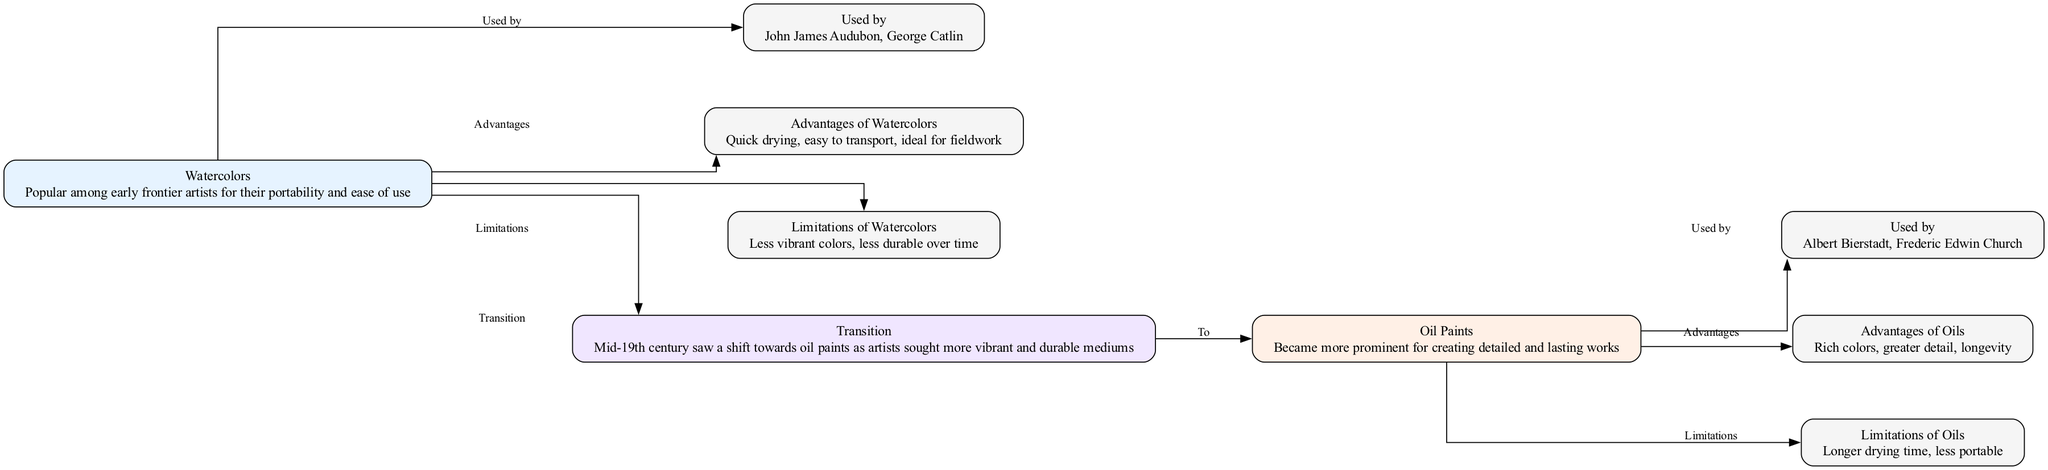What are the advantages of watercolors? The diagram lists advantages under the "Watercolors" node. Specifically, it mentions "Quick drying, easy to transport, ideal for fieldwork".
Answer: Quick drying, easy to transport, ideal for fieldwork Who are two artists that used oil paints? The "Used by" node linked to "Oil Paints" shows the names of artists. The diagram identifies "Albert Bierstadt, Frederic Edwin Church".
Answer: Albert Bierstadt, Frederic Edwin Church How many nodes are present in the diagram? Counting all unique nodes as listed in the diagram, there are a total of 9 nodes: watercolors, used by, advantages of watercolors, limitations of watercolors, transition, oil paints, used by oil, advantages of oils, limitations of oils.
Answer: 9 What transition occurred in the mid-19th century? The "Transition" node states that "Mid-19th century saw a shift towards oil paints as artists sought more vibrant and durable mediums". This indicates the movement from watercolors to oil paints.
Answer: Shift towards oil paints What are the limitations of oil paints? The diagram specifies limitations under the "Oil Paints" node, indicating "Longer drying time, less portable".
Answer: Longer drying time, less portable Which paint medium is described as having rich colors? Under the "Advantages of Oils" node, it states "Rich colors". This indicates that the oil paints are the medium being described.
Answer: Oils Why did artists transition from watercolors to oil paints? The "Transition" node specifically states that artists sought "more vibrant and durable mediums". This suggests that the desire for better quality led to the transition.
Answer: More vibrant and durable mediums What is a common limitation mentioned for both mediums? When comparing the limitations connected to both watercolors and oil paints, the diagram highlights that both have durability issues; specifically, watercolors are "less durable over time" and oil paints are "less portable".
Answer: Less durable over time (watercolors) and less portable (oils) 